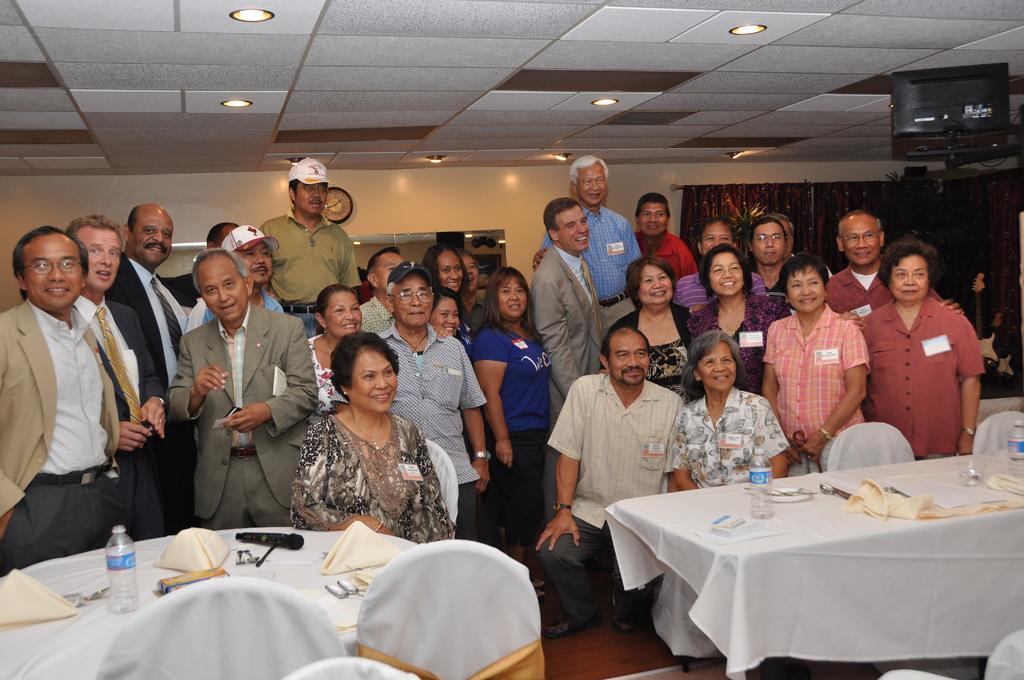Describe this image in one or two sentences. There are many people standing in this room. Three of them were sitting in the chairs. There are some tables on which water bottles and some clothes, tissues were present. In front of them there are some chairs. There are men and women in this group. 